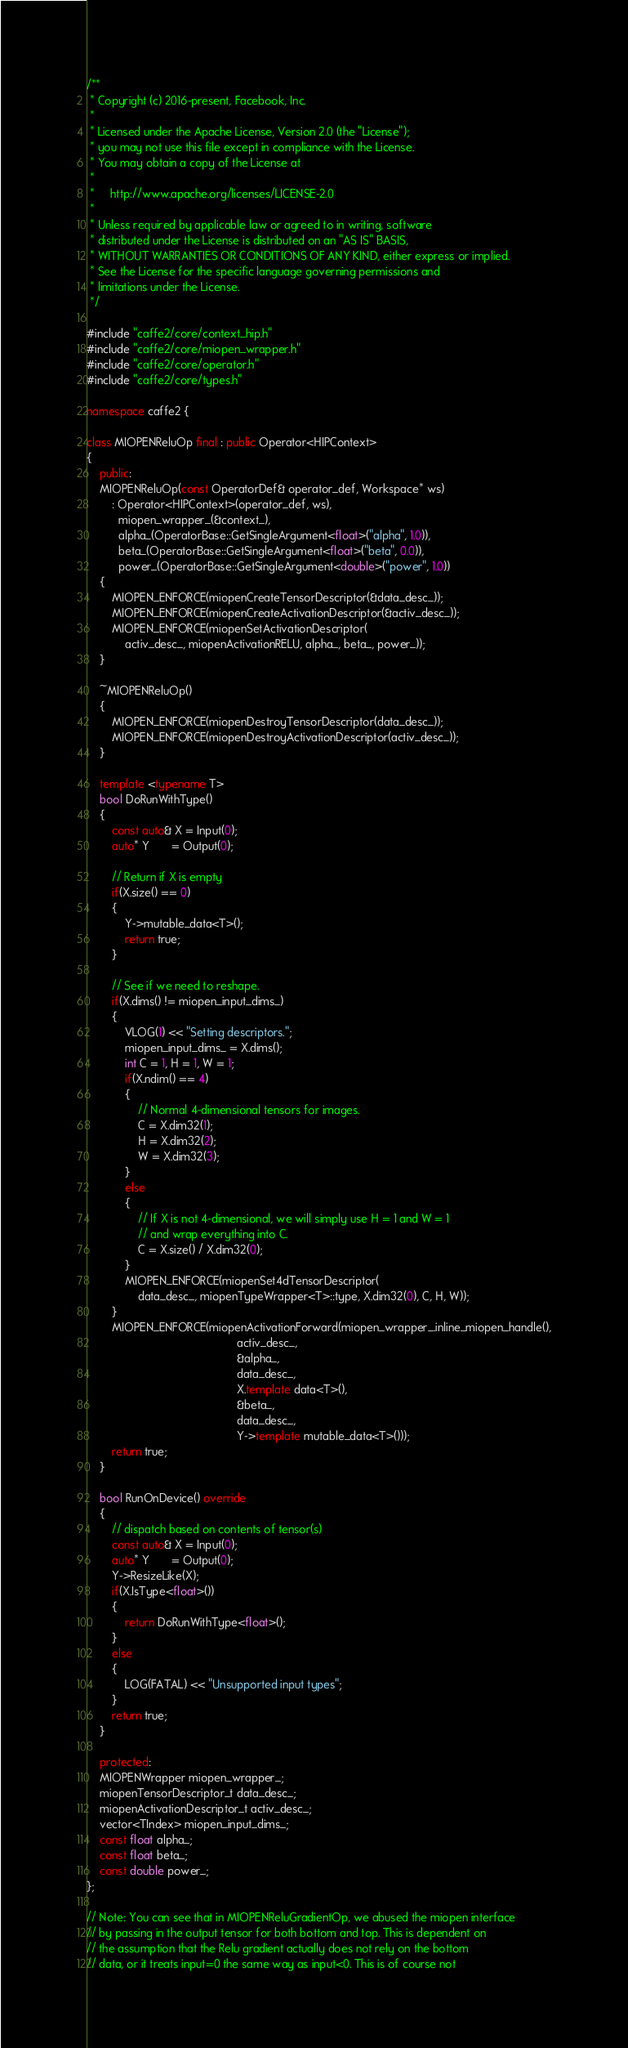Convert code to text. <code><loc_0><loc_0><loc_500><loc_500><_C++_>/**
 * Copyright (c) 2016-present, Facebook, Inc.
 *
 * Licensed under the Apache License, Version 2.0 (the "License");
 * you may not use this file except in compliance with the License.
 * You may obtain a copy of the License at
 *
 *     http://www.apache.org/licenses/LICENSE-2.0
 *
 * Unless required by applicable law or agreed to in writing, software
 * distributed under the License is distributed on an "AS IS" BASIS,
 * WITHOUT WARRANTIES OR CONDITIONS OF ANY KIND, either express or implied.
 * See the License for the specific language governing permissions and
 * limitations under the License.
 */

#include "caffe2/core/context_hip.h"
#include "caffe2/core/miopen_wrapper.h"
#include "caffe2/core/operator.h"
#include "caffe2/core/types.h"

namespace caffe2 {

class MIOPENReluOp final : public Operator<HIPContext>
{
    public:
    MIOPENReluOp(const OperatorDef& operator_def, Workspace* ws)
        : Operator<HIPContext>(operator_def, ws),
          miopen_wrapper_(&context_),
          alpha_(OperatorBase::GetSingleArgument<float>("alpha", 1.0)),
          beta_(OperatorBase::GetSingleArgument<float>("beta", 0.0)),
          power_(OperatorBase::GetSingleArgument<double>("power", 1.0))
    {
        MIOPEN_ENFORCE(miopenCreateTensorDescriptor(&data_desc_));
        MIOPEN_ENFORCE(miopenCreateActivationDescriptor(&activ_desc_));
        MIOPEN_ENFORCE(miopenSetActivationDescriptor(
            activ_desc_, miopenActivationRELU, alpha_, beta_, power_));
    }

    ~MIOPENReluOp()
    {
        MIOPEN_ENFORCE(miopenDestroyTensorDescriptor(data_desc_));
        MIOPEN_ENFORCE(miopenDestroyActivationDescriptor(activ_desc_));
    }

    template <typename T>
    bool DoRunWithType()
    {
        const auto& X = Input(0);
        auto* Y       = Output(0);

        // Return if X is empty
        if(X.size() == 0)
        {
            Y->mutable_data<T>();
            return true;
        }

        // See if we need to reshape.
        if(X.dims() != miopen_input_dims_)
        {
            VLOG(1) << "Setting descriptors.";
            miopen_input_dims_ = X.dims();
            int C = 1, H = 1, W = 1;
            if(X.ndim() == 4)
            {
                // Normal 4-dimensional tensors for images.
                C = X.dim32(1);
                H = X.dim32(2);
                W = X.dim32(3);
            }
            else
            {
                // If X is not 4-dimensional, we will simply use H = 1 and W = 1
                // and wrap everything into C.
                C = X.size() / X.dim32(0);
            }
            MIOPEN_ENFORCE(miopenSet4dTensorDescriptor(
                data_desc_, miopenTypeWrapper<T>::type, X.dim32(0), C, H, W));
        }
        MIOPEN_ENFORCE(miopenActivationForward(miopen_wrapper_.inline_miopen_handle(),
                                               activ_desc_,
                                               &alpha_,
                                               data_desc_,
                                               X.template data<T>(),
                                               &beta_,
                                               data_desc_,
                                               Y->template mutable_data<T>()));
        return true;
    }

    bool RunOnDevice() override
    {
        // dispatch based on contents of tensor(s)
        const auto& X = Input(0);
        auto* Y       = Output(0);
        Y->ResizeLike(X);
        if(X.IsType<float>())
        {
            return DoRunWithType<float>();
        }
        else
        {
            LOG(FATAL) << "Unsupported input types";
        }
        return true;
    }

    protected:
    MIOPENWrapper miopen_wrapper_;
    miopenTensorDescriptor_t data_desc_;
    miopenActivationDescriptor_t activ_desc_;
    vector<TIndex> miopen_input_dims_;
    const float alpha_;
    const float beta_;
    const double power_;
};

// Note: You can see that in MIOPENReluGradientOp, we abused the miopen interface
// by passing in the output tensor for both bottom and top. This is dependent on
// the assumption that the Relu gradient actually does not rely on the bottom
// data, or it treats input=0 the same way as input<0. This is of course not</code> 